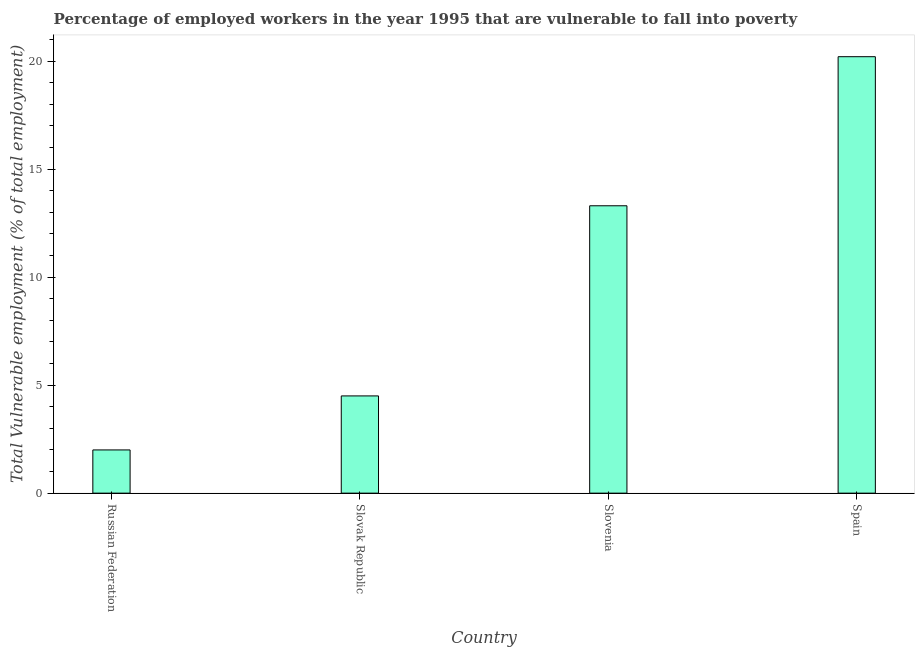What is the title of the graph?
Provide a short and direct response. Percentage of employed workers in the year 1995 that are vulnerable to fall into poverty. What is the label or title of the Y-axis?
Make the answer very short. Total Vulnerable employment (% of total employment). What is the total vulnerable employment in Slovenia?
Your answer should be compact. 13.3. Across all countries, what is the maximum total vulnerable employment?
Your answer should be compact. 20.2. Across all countries, what is the minimum total vulnerable employment?
Keep it short and to the point. 2. In which country was the total vulnerable employment minimum?
Give a very brief answer. Russian Federation. What is the sum of the total vulnerable employment?
Keep it short and to the point. 40. What is the difference between the total vulnerable employment in Russian Federation and Slovak Republic?
Your response must be concise. -2.5. What is the average total vulnerable employment per country?
Your answer should be very brief. 10. What is the median total vulnerable employment?
Your answer should be compact. 8.9. What is the ratio of the total vulnerable employment in Slovenia to that in Spain?
Make the answer very short. 0.66. Is the total vulnerable employment in Russian Federation less than that in Slovenia?
Your answer should be very brief. Yes. What is the difference between the highest and the second highest total vulnerable employment?
Your answer should be compact. 6.9. How many bars are there?
Give a very brief answer. 4. How many countries are there in the graph?
Offer a very short reply. 4. What is the Total Vulnerable employment (% of total employment) of Slovenia?
Give a very brief answer. 13.3. What is the Total Vulnerable employment (% of total employment) in Spain?
Offer a terse response. 20.2. What is the difference between the Total Vulnerable employment (% of total employment) in Russian Federation and Slovak Republic?
Give a very brief answer. -2.5. What is the difference between the Total Vulnerable employment (% of total employment) in Russian Federation and Spain?
Your answer should be very brief. -18.2. What is the difference between the Total Vulnerable employment (% of total employment) in Slovak Republic and Slovenia?
Your answer should be compact. -8.8. What is the difference between the Total Vulnerable employment (% of total employment) in Slovak Republic and Spain?
Provide a succinct answer. -15.7. What is the ratio of the Total Vulnerable employment (% of total employment) in Russian Federation to that in Slovak Republic?
Offer a terse response. 0.44. What is the ratio of the Total Vulnerable employment (% of total employment) in Russian Federation to that in Slovenia?
Provide a short and direct response. 0.15. What is the ratio of the Total Vulnerable employment (% of total employment) in Russian Federation to that in Spain?
Provide a short and direct response. 0.1. What is the ratio of the Total Vulnerable employment (% of total employment) in Slovak Republic to that in Slovenia?
Provide a succinct answer. 0.34. What is the ratio of the Total Vulnerable employment (% of total employment) in Slovak Republic to that in Spain?
Your answer should be compact. 0.22. What is the ratio of the Total Vulnerable employment (% of total employment) in Slovenia to that in Spain?
Provide a short and direct response. 0.66. 